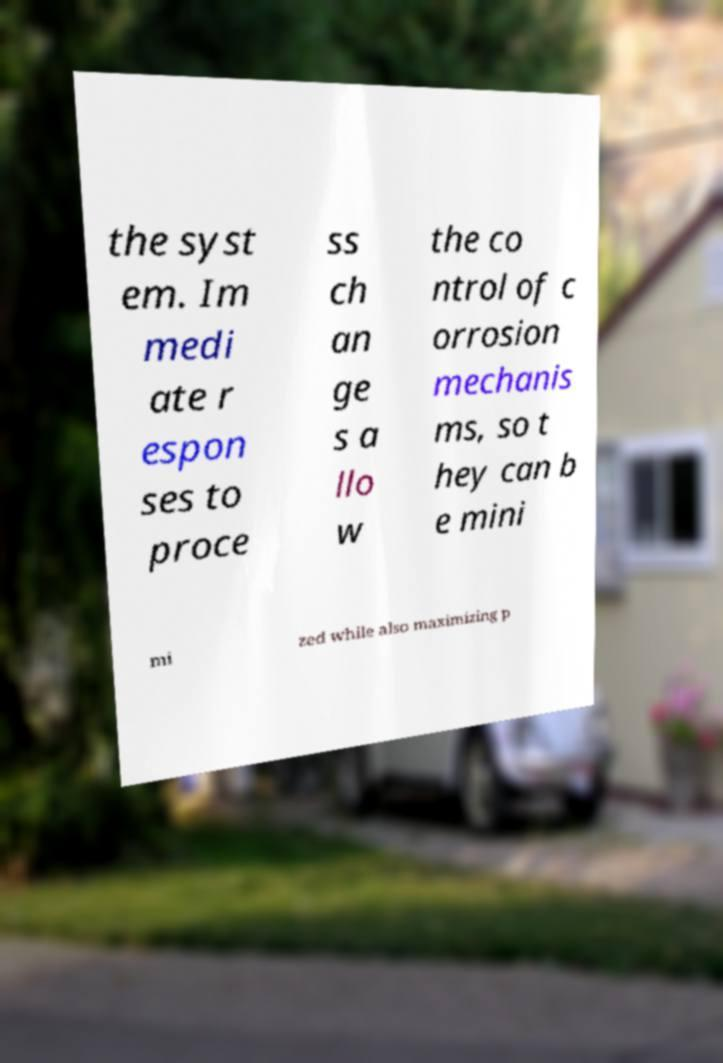Can you accurately transcribe the text from the provided image for me? the syst em. Im medi ate r espon ses to proce ss ch an ge s a llo w the co ntrol of c orrosion mechanis ms, so t hey can b e mini mi zed while also maximizing p 